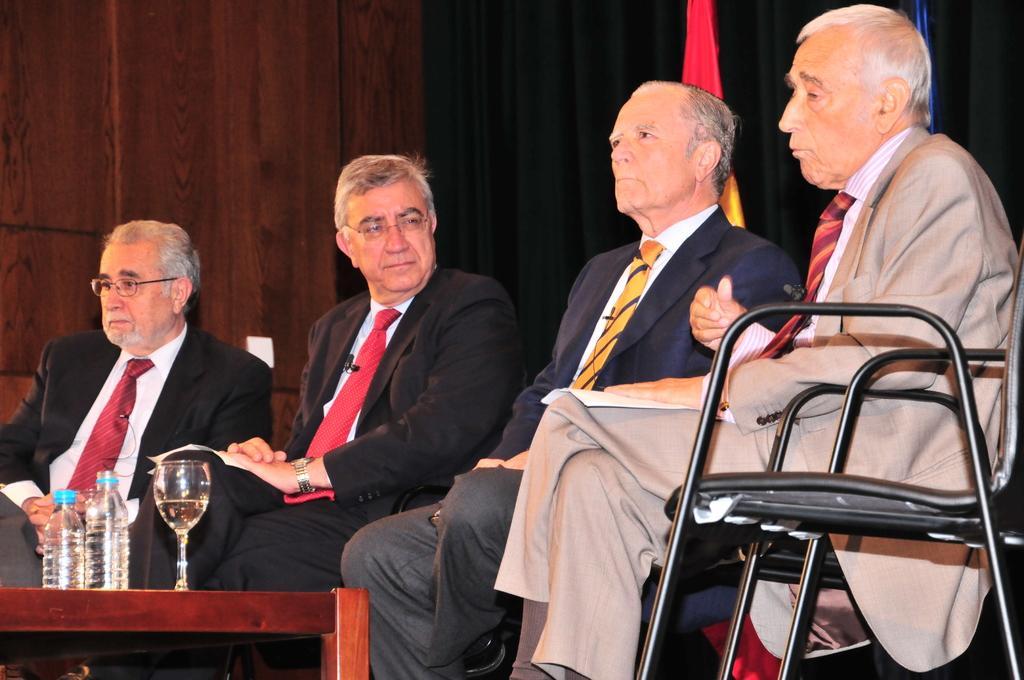Describe this image in one or two sentences. In the image we can see four men wearing clothes, tie and two of them are wearing spectacles. They are sitting on the chair, this is a table, on the table there is a wine glass and water bottles. This is a flag and a wooden wall. 